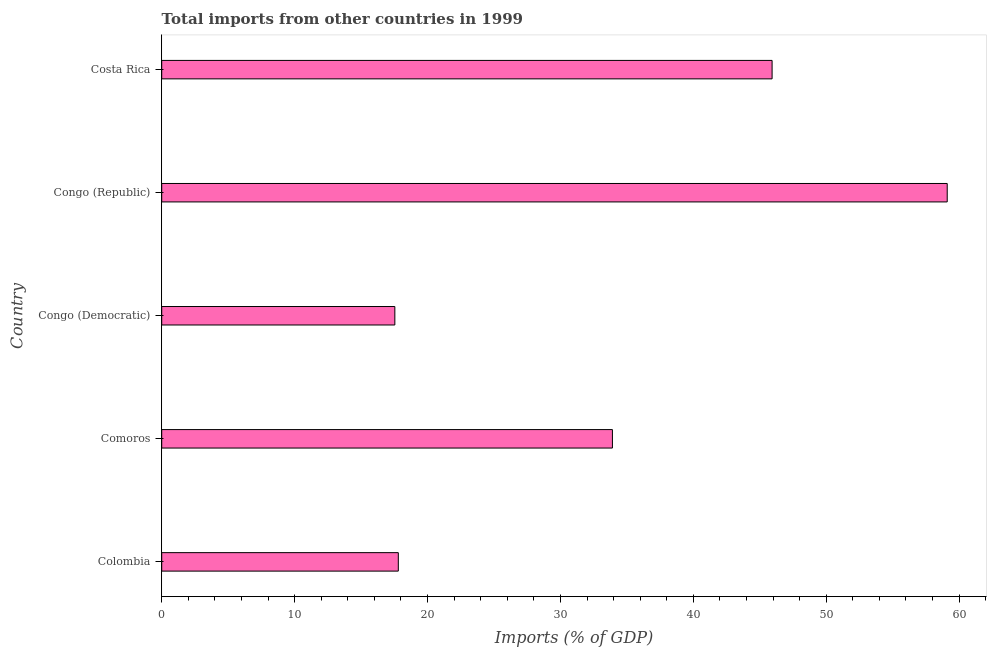Does the graph contain any zero values?
Your answer should be very brief. No. What is the title of the graph?
Make the answer very short. Total imports from other countries in 1999. What is the label or title of the X-axis?
Ensure brevity in your answer.  Imports (% of GDP). What is the label or title of the Y-axis?
Your answer should be compact. Country. What is the total imports in Costa Rica?
Provide a succinct answer. 45.93. Across all countries, what is the maximum total imports?
Keep it short and to the point. 59.1. Across all countries, what is the minimum total imports?
Make the answer very short. 17.54. In which country was the total imports maximum?
Offer a terse response. Congo (Republic). In which country was the total imports minimum?
Offer a very short reply. Congo (Democratic). What is the sum of the total imports?
Provide a short and direct response. 174.29. What is the difference between the total imports in Comoros and Congo (Republic)?
Make the answer very short. -25.19. What is the average total imports per country?
Make the answer very short. 34.86. What is the median total imports?
Your answer should be very brief. 33.91. In how many countries, is the total imports greater than 40 %?
Keep it short and to the point. 2. What is the ratio of the total imports in Comoros to that in Congo (Republic)?
Ensure brevity in your answer.  0.57. Is the total imports in Comoros less than that in Congo (Democratic)?
Your answer should be very brief. No. What is the difference between the highest and the second highest total imports?
Make the answer very short. 13.18. What is the difference between the highest and the lowest total imports?
Your response must be concise. 41.56. What is the difference between two consecutive major ticks on the X-axis?
Offer a terse response. 10. Are the values on the major ticks of X-axis written in scientific E-notation?
Your answer should be compact. No. What is the Imports (% of GDP) of Colombia?
Offer a very short reply. 17.8. What is the Imports (% of GDP) of Comoros?
Your answer should be very brief. 33.91. What is the Imports (% of GDP) of Congo (Democratic)?
Make the answer very short. 17.54. What is the Imports (% of GDP) of Congo (Republic)?
Provide a short and direct response. 59.1. What is the Imports (% of GDP) in Costa Rica?
Make the answer very short. 45.93. What is the difference between the Imports (% of GDP) in Colombia and Comoros?
Provide a short and direct response. -16.11. What is the difference between the Imports (% of GDP) in Colombia and Congo (Democratic)?
Keep it short and to the point. 0.26. What is the difference between the Imports (% of GDP) in Colombia and Congo (Republic)?
Keep it short and to the point. -41.3. What is the difference between the Imports (% of GDP) in Colombia and Costa Rica?
Make the answer very short. -28.12. What is the difference between the Imports (% of GDP) in Comoros and Congo (Democratic)?
Your answer should be compact. 16.37. What is the difference between the Imports (% of GDP) in Comoros and Congo (Republic)?
Give a very brief answer. -25.19. What is the difference between the Imports (% of GDP) in Comoros and Costa Rica?
Your answer should be compact. -12.01. What is the difference between the Imports (% of GDP) in Congo (Democratic) and Congo (Republic)?
Your response must be concise. -41.56. What is the difference between the Imports (% of GDP) in Congo (Democratic) and Costa Rica?
Ensure brevity in your answer.  -28.39. What is the difference between the Imports (% of GDP) in Congo (Republic) and Costa Rica?
Your response must be concise. 13.18. What is the ratio of the Imports (% of GDP) in Colombia to that in Comoros?
Keep it short and to the point. 0.53. What is the ratio of the Imports (% of GDP) in Colombia to that in Congo (Democratic)?
Ensure brevity in your answer.  1.01. What is the ratio of the Imports (% of GDP) in Colombia to that in Congo (Republic)?
Ensure brevity in your answer.  0.3. What is the ratio of the Imports (% of GDP) in Colombia to that in Costa Rica?
Provide a short and direct response. 0.39. What is the ratio of the Imports (% of GDP) in Comoros to that in Congo (Democratic)?
Your answer should be very brief. 1.93. What is the ratio of the Imports (% of GDP) in Comoros to that in Congo (Republic)?
Give a very brief answer. 0.57. What is the ratio of the Imports (% of GDP) in Comoros to that in Costa Rica?
Your answer should be compact. 0.74. What is the ratio of the Imports (% of GDP) in Congo (Democratic) to that in Congo (Republic)?
Your response must be concise. 0.3. What is the ratio of the Imports (% of GDP) in Congo (Democratic) to that in Costa Rica?
Provide a short and direct response. 0.38. What is the ratio of the Imports (% of GDP) in Congo (Republic) to that in Costa Rica?
Keep it short and to the point. 1.29. 